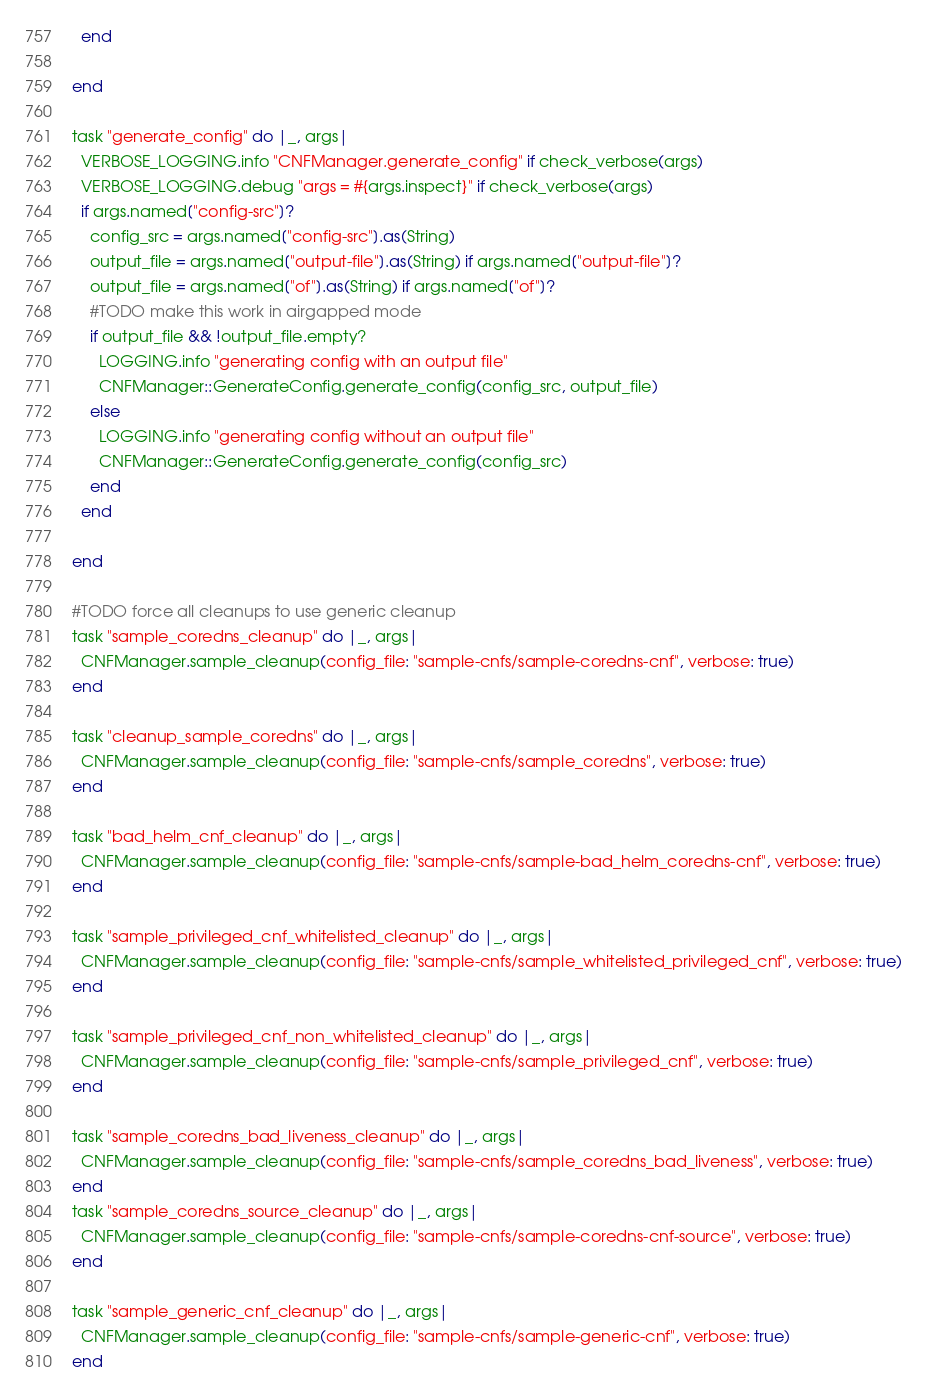Convert code to text. <code><loc_0><loc_0><loc_500><loc_500><_Crystal_>  end

end

task "generate_config" do |_, args|
  VERBOSE_LOGGING.info "CNFManager.generate_config" if check_verbose(args)
  VERBOSE_LOGGING.debug "args = #{args.inspect}" if check_verbose(args)
  if args.named["config-src"]? 
    config_src = args.named["config-src"].as(String)
    output_file = args.named["output-file"].as(String) if args.named["output-file"]?
    output_file = args.named["of"].as(String) if args.named["of"]?
    #TODO make this work in airgapped mode
    if output_file && !output_file.empty?
      LOGGING.info "generating config with an output file"
      CNFManager::GenerateConfig.generate_config(config_src, output_file)
    else
      LOGGING.info "generating config without an output file"
      CNFManager::GenerateConfig.generate_config(config_src)
    end
  end

end

#TODO force all cleanups to use generic cleanup
task "sample_coredns_cleanup" do |_, args|
  CNFManager.sample_cleanup(config_file: "sample-cnfs/sample-coredns-cnf", verbose: true)
end

task "cleanup_sample_coredns" do |_, args|
  CNFManager.sample_cleanup(config_file: "sample-cnfs/sample_coredns", verbose: true)
end

task "bad_helm_cnf_cleanup" do |_, args|
  CNFManager.sample_cleanup(config_file: "sample-cnfs/sample-bad_helm_coredns-cnf", verbose: true)
end

task "sample_privileged_cnf_whitelisted_cleanup" do |_, args|
  CNFManager.sample_cleanup(config_file: "sample-cnfs/sample_whitelisted_privileged_cnf", verbose: true)
end

task "sample_privileged_cnf_non_whitelisted_cleanup" do |_, args|
  CNFManager.sample_cleanup(config_file: "sample-cnfs/sample_privileged_cnf", verbose: true)
end

task "sample_coredns_bad_liveness_cleanup" do |_, args|
  CNFManager.sample_cleanup(config_file: "sample-cnfs/sample_coredns_bad_liveness", verbose: true)
end
task "sample_coredns_source_cleanup" do |_, args|
  CNFManager.sample_cleanup(config_file: "sample-cnfs/sample-coredns-cnf-source", verbose: true)
end

task "sample_generic_cnf_cleanup" do |_, args|
  CNFManager.sample_cleanup(config_file: "sample-cnfs/sample-generic-cnf", verbose: true)
end
</code> 